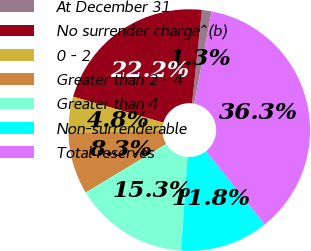Convert chart to OTSL. <chart><loc_0><loc_0><loc_500><loc_500><pie_chart><fcel>At December 31<fcel>No surrender charge^(b)<fcel>0 - 2<fcel>Greater than 2 - 4<fcel>Greater than 4<fcel>Non-surrenderable<fcel>Total reserves<nl><fcel>1.3%<fcel>22.21%<fcel>4.8%<fcel>8.3%<fcel>15.3%<fcel>11.8%<fcel>36.29%<nl></chart> 